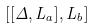Convert formula to latex. <formula><loc_0><loc_0><loc_500><loc_500>[ [ \Delta , L _ { a } ] , L _ { b } ]</formula> 